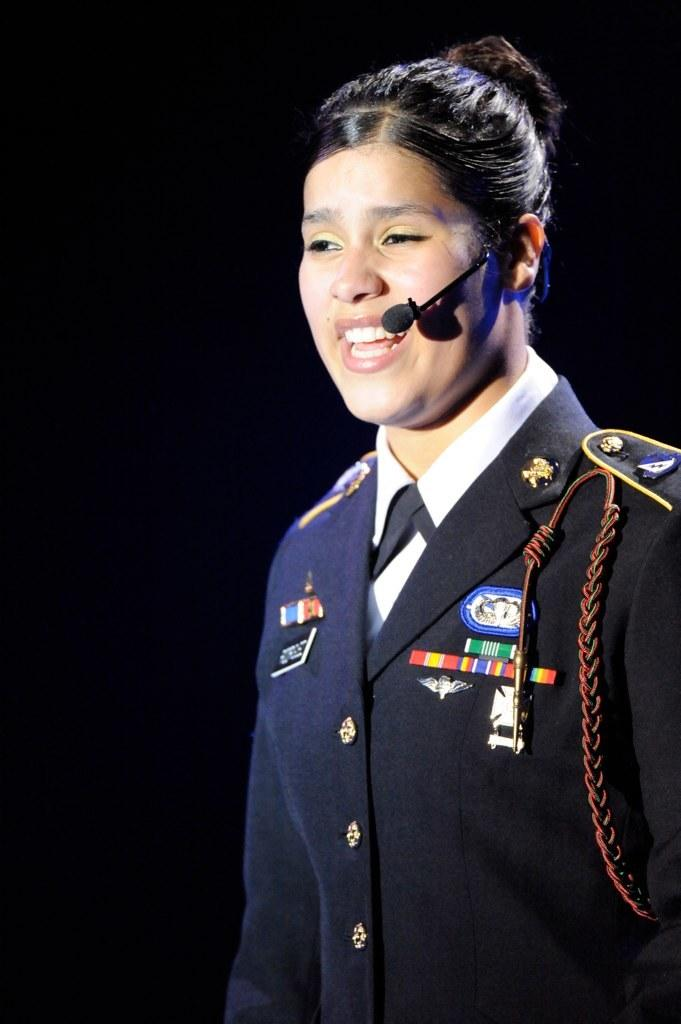Who is the main subject in the image? There is a woman in the image. What is the woman wearing? The woman is wearing a uniform and a microphone. What is the woman doing in the image? The woman is speaking. What is the color of the background in the image? The background of the image is dark in color. How many ovens can be seen in the image? There are no ovens present in the image. Can you describe the woman's eyes in the image? The provided facts do not mention the woman's eyes, so we cannot describe them. 